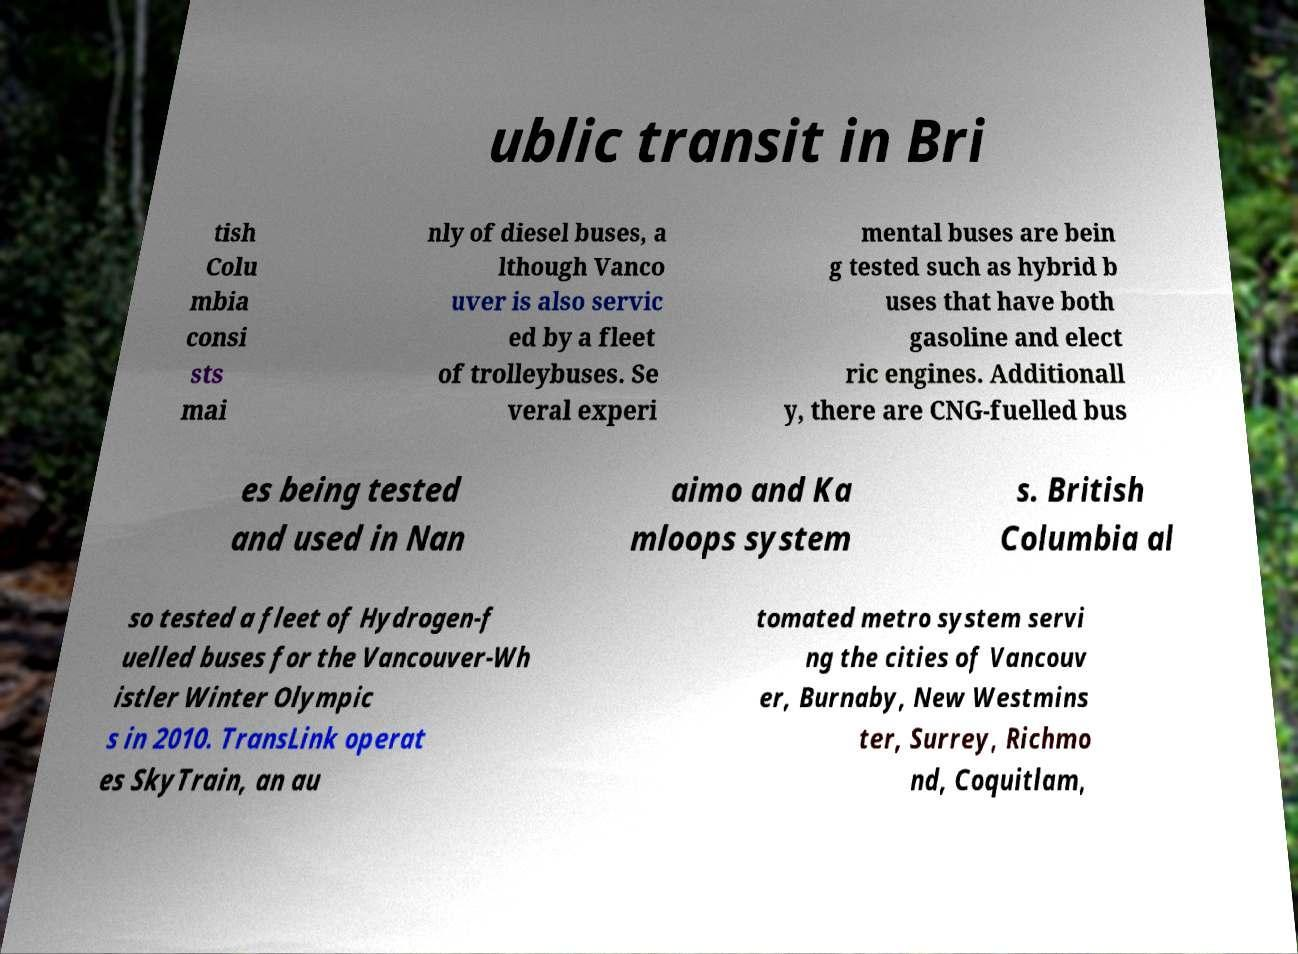Could you assist in decoding the text presented in this image and type it out clearly? ublic transit in Bri tish Colu mbia consi sts mai nly of diesel buses, a lthough Vanco uver is also servic ed by a fleet of trolleybuses. Se veral experi mental buses are bein g tested such as hybrid b uses that have both gasoline and elect ric engines. Additionall y, there are CNG-fuelled bus es being tested and used in Nan aimo and Ka mloops system s. British Columbia al so tested a fleet of Hydrogen-f uelled buses for the Vancouver-Wh istler Winter Olympic s in 2010. TransLink operat es SkyTrain, an au tomated metro system servi ng the cities of Vancouv er, Burnaby, New Westmins ter, Surrey, Richmo nd, Coquitlam, 